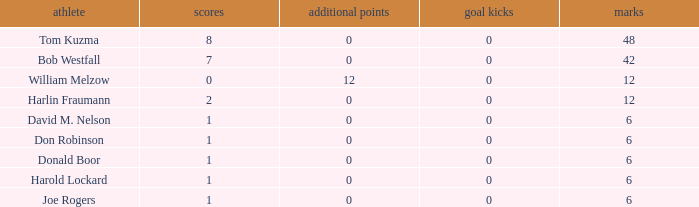Name the points for donald boor 6.0. 